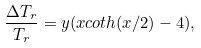Convert formula to latex. <formula><loc_0><loc_0><loc_500><loc_500>\frac { \Delta T _ { r } } { T _ { r } } = y ( x c o t h ( x / 2 ) - 4 ) ,</formula> 